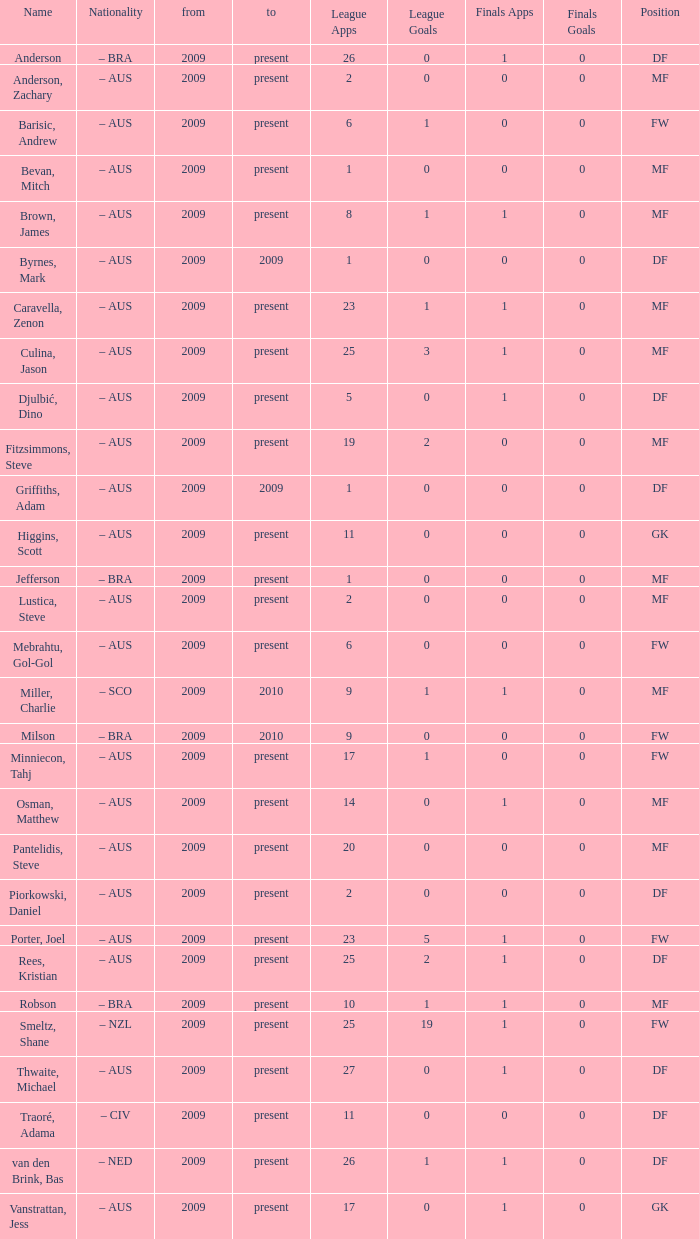Can you list the 19 best league apps? Present. 